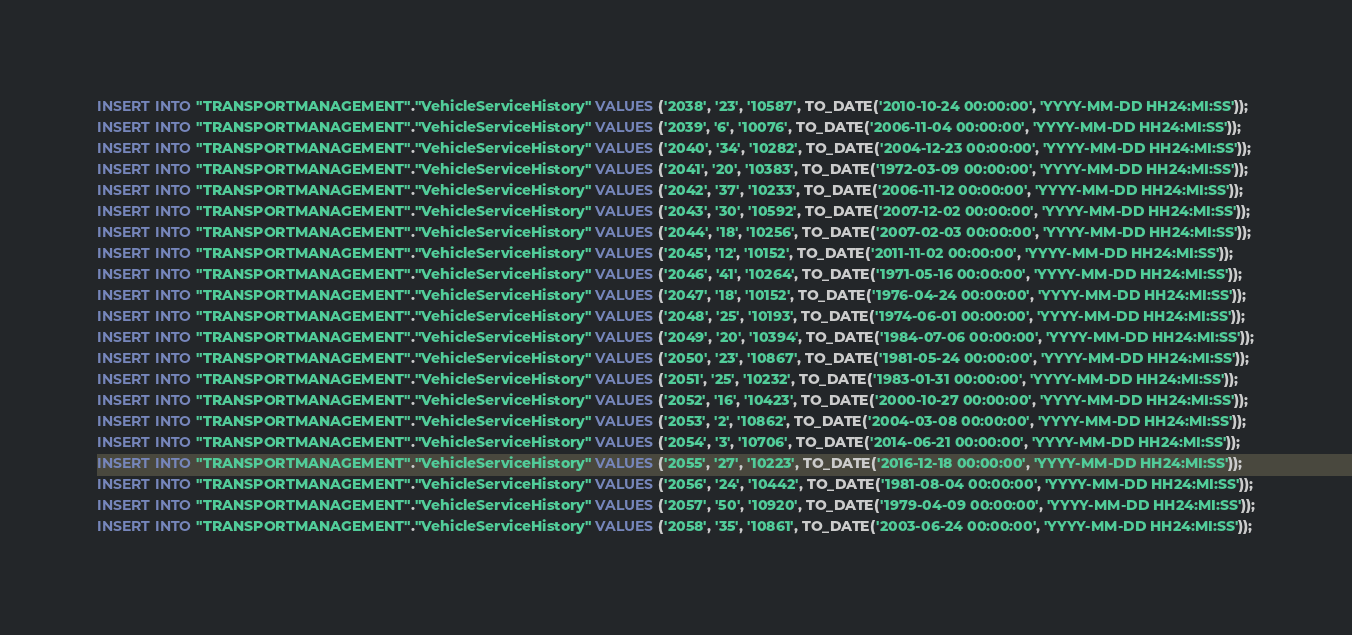Convert code to text. <code><loc_0><loc_0><loc_500><loc_500><_SQL_>INSERT INTO "TRANSPORTMANAGEMENT"."VehicleServiceHistory" VALUES ('2038', '23', '10587', TO_DATE('2010-10-24 00:00:00', 'YYYY-MM-DD HH24:MI:SS'));
INSERT INTO "TRANSPORTMANAGEMENT"."VehicleServiceHistory" VALUES ('2039', '6', '10076', TO_DATE('2006-11-04 00:00:00', 'YYYY-MM-DD HH24:MI:SS'));
INSERT INTO "TRANSPORTMANAGEMENT"."VehicleServiceHistory" VALUES ('2040', '34', '10282', TO_DATE('2004-12-23 00:00:00', 'YYYY-MM-DD HH24:MI:SS'));
INSERT INTO "TRANSPORTMANAGEMENT"."VehicleServiceHistory" VALUES ('2041', '20', '10383', TO_DATE('1972-03-09 00:00:00', 'YYYY-MM-DD HH24:MI:SS'));
INSERT INTO "TRANSPORTMANAGEMENT"."VehicleServiceHistory" VALUES ('2042', '37', '10233', TO_DATE('2006-11-12 00:00:00', 'YYYY-MM-DD HH24:MI:SS'));
INSERT INTO "TRANSPORTMANAGEMENT"."VehicleServiceHistory" VALUES ('2043', '30', '10592', TO_DATE('2007-12-02 00:00:00', 'YYYY-MM-DD HH24:MI:SS'));
INSERT INTO "TRANSPORTMANAGEMENT"."VehicleServiceHistory" VALUES ('2044', '18', '10256', TO_DATE('2007-02-03 00:00:00', 'YYYY-MM-DD HH24:MI:SS'));
INSERT INTO "TRANSPORTMANAGEMENT"."VehicleServiceHistory" VALUES ('2045', '12', '10152', TO_DATE('2011-11-02 00:00:00', 'YYYY-MM-DD HH24:MI:SS'));
INSERT INTO "TRANSPORTMANAGEMENT"."VehicleServiceHistory" VALUES ('2046', '41', '10264', TO_DATE('1971-05-16 00:00:00', 'YYYY-MM-DD HH24:MI:SS'));
INSERT INTO "TRANSPORTMANAGEMENT"."VehicleServiceHistory" VALUES ('2047', '18', '10152', TO_DATE('1976-04-24 00:00:00', 'YYYY-MM-DD HH24:MI:SS'));
INSERT INTO "TRANSPORTMANAGEMENT"."VehicleServiceHistory" VALUES ('2048', '25', '10193', TO_DATE('1974-06-01 00:00:00', 'YYYY-MM-DD HH24:MI:SS'));
INSERT INTO "TRANSPORTMANAGEMENT"."VehicleServiceHistory" VALUES ('2049', '20', '10394', TO_DATE('1984-07-06 00:00:00', 'YYYY-MM-DD HH24:MI:SS'));
INSERT INTO "TRANSPORTMANAGEMENT"."VehicleServiceHistory" VALUES ('2050', '23', '10867', TO_DATE('1981-05-24 00:00:00', 'YYYY-MM-DD HH24:MI:SS'));
INSERT INTO "TRANSPORTMANAGEMENT"."VehicleServiceHistory" VALUES ('2051', '25', '10232', TO_DATE('1983-01-31 00:00:00', 'YYYY-MM-DD HH24:MI:SS'));
INSERT INTO "TRANSPORTMANAGEMENT"."VehicleServiceHistory" VALUES ('2052', '16', '10423', TO_DATE('2000-10-27 00:00:00', 'YYYY-MM-DD HH24:MI:SS'));
INSERT INTO "TRANSPORTMANAGEMENT"."VehicleServiceHistory" VALUES ('2053', '2', '10862', TO_DATE('2004-03-08 00:00:00', 'YYYY-MM-DD HH24:MI:SS'));
INSERT INTO "TRANSPORTMANAGEMENT"."VehicleServiceHistory" VALUES ('2054', '3', '10706', TO_DATE('2014-06-21 00:00:00', 'YYYY-MM-DD HH24:MI:SS'));
INSERT INTO "TRANSPORTMANAGEMENT"."VehicleServiceHistory" VALUES ('2055', '27', '10223', TO_DATE('2016-12-18 00:00:00', 'YYYY-MM-DD HH24:MI:SS'));
INSERT INTO "TRANSPORTMANAGEMENT"."VehicleServiceHistory" VALUES ('2056', '24', '10442', TO_DATE('1981-08-04 00:00:00', 'YYYY-MM-DD HH24:MI:SS'));
INSERT INTO "TRANSPORTMANAGEMENT"."VehicleServiceHistory" VALUES ('2057', '50', '10920', TO_DATE('1979-04-09 00:00:00', 'YYYY-MM-DD HH24:MI:SS'));
INSERT INTO "TRANSPORTMANAGEMENT"."VehicleServiceHistory" VALUES ('2058', '35', '10861', TO_DATE('2003-06-24 00:00:00', 'YYYY-MM-DD HH24:MI:SS'));</code> 